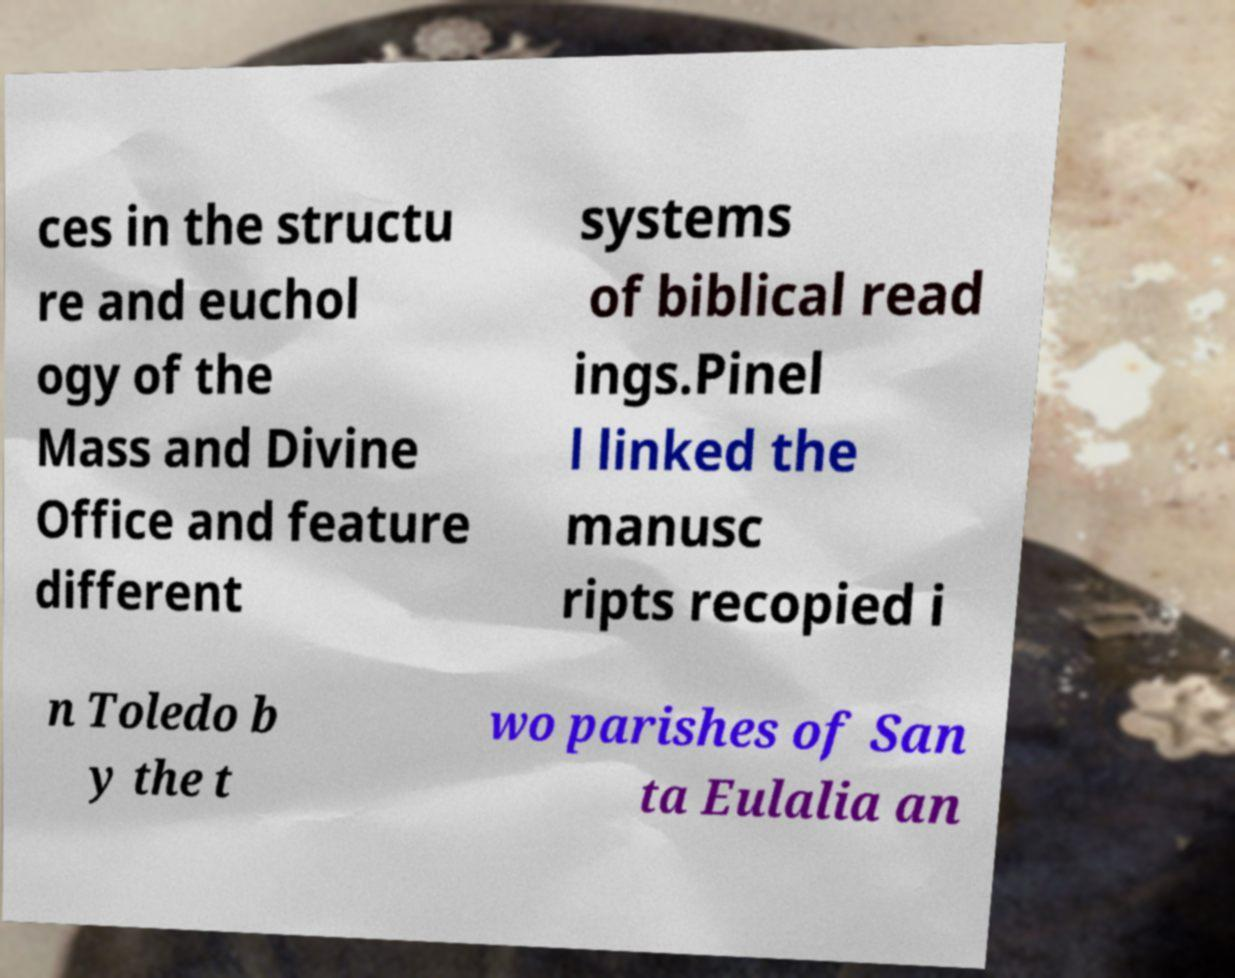There's text embedded in this image that I need extracted. Can you transcribe it verbatim? ces in the structu re and euchol ogy of the Mass and Divine Office and feature different systems of biblical read ings.Pinel l linked the manusc ripts recopied i n Toledo b y the t wo parishes of San ta Eulalia an 